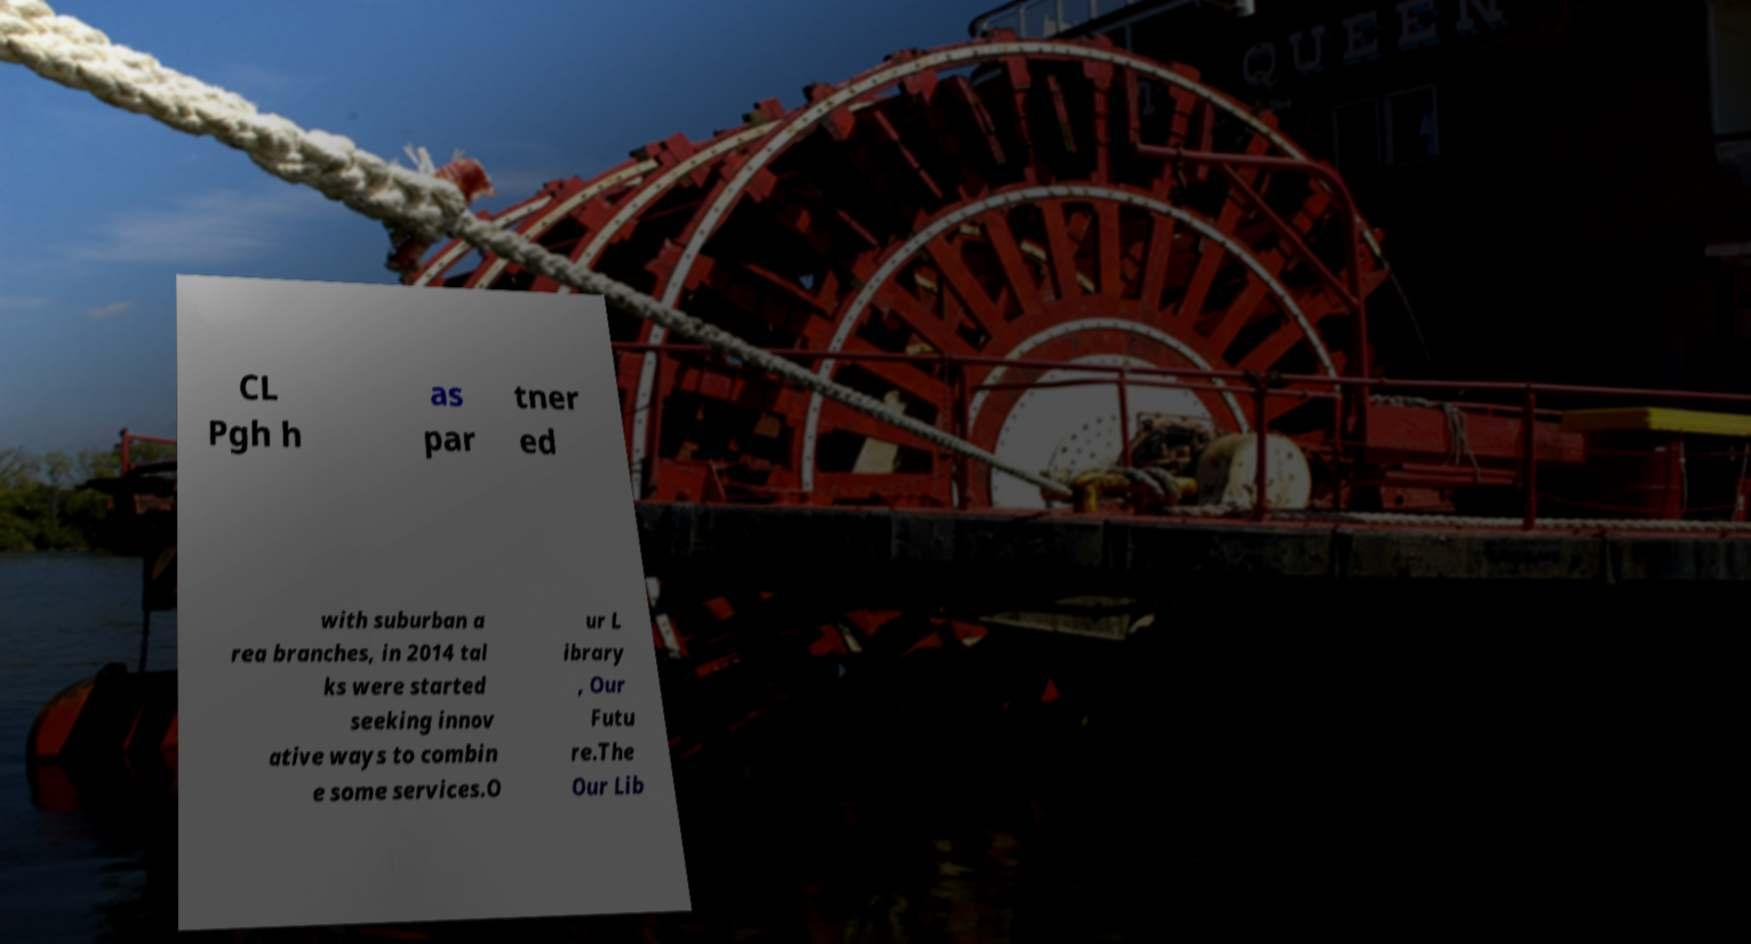Please read and relay the text visible in this image. What does it say? CL Pgh h as par tner ed with suburban a rea branches, in 2014 tal ks were started seeking innov ative ways to combin e some services.O ur L ibrary , Our Futu re.The Our Lib 